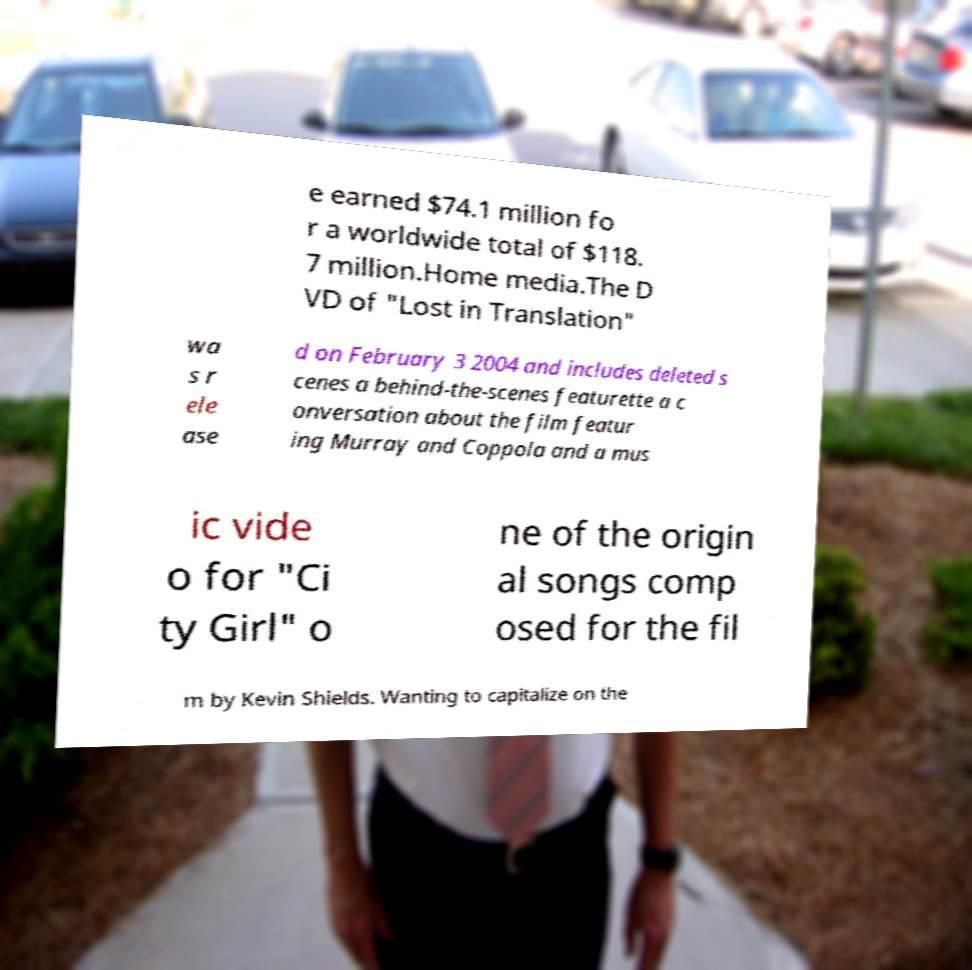Could you extract and type out the text from this image? e earned $74.1 million fo r a worldwide total of $118. 7 million.Home media.The D VD of "Lost in Translation" wa s r ele ase d on February 3 2004 and includes deleted s cenes a behind-the-scenes featurette a c onversation about the film featur ing Murray and Coppola and a mus ic vide o for "Ci ty Girl" o ne of the origin al songs comp osed for the fil m by Kevin Shields. Wanting to capitalize on the 